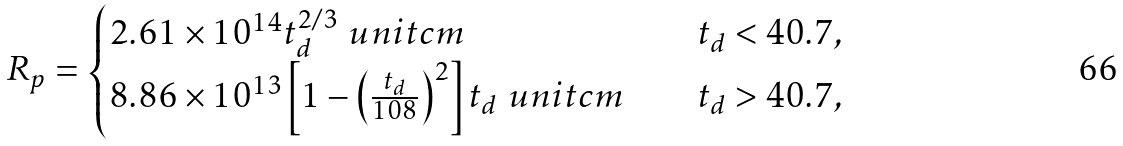Convert formula to latex. <formula><loc_0><loc_0><loc_500><loc_500>R _ { p } = \begin{cases} 2 . 6 1 \times 1 0 ^ { 1 4 } t _ { d } ^ { 2 / 3 } \ u n i t { c m } & \quad t _ { d } < 4 0 . 7 , \\ 8 . 8 6 \times 1 0 ^ { 1 3 } \left [ 1 - \left ( \frac { t _ { d } } { 1 0 8 } \right ) ^ { 2 } \right ] t _ { d } \ u n i t { c m } & \quad t _ { d } > 4 0 . 7 , \end{cases}</formula> 